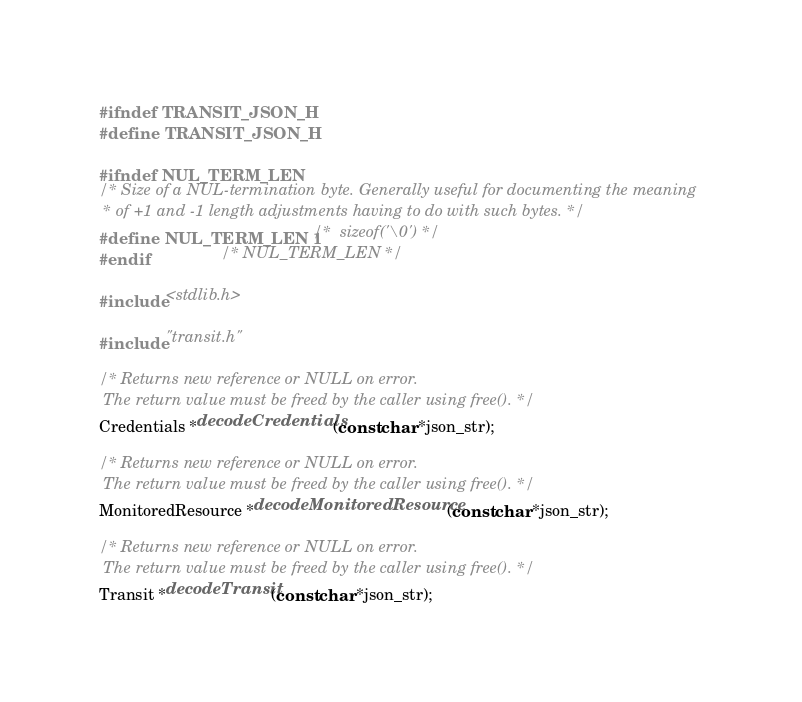<code> <loc_0><loc_0><loc_500><loc_500><_C_>#ifndef TRANSIT_JSON_H
#define TRANSIT_JSON_H

#ifndef NUL_TERM_LEN
/* Size of a NUL-termination byte. Generally useful for documenting the meaning
 * of +1 and -1 length adjustments having to do with such bytes. */
#define NUL_TERM_LEN 1 /*  sizeof('\0') */
#endif                 /* NUL_TERM_LEN */

#include <stdlib.h>

#include "transit.h"

/* Returns new reference or NULL on error.
 The return value must be freed by the caller using free(). */
Credentials *decodeCredentials(const char *json_str);

/* Returns new reference or NULL on error.
 The return value must be freed by the caller using free(). */
MonitoredResource *decodeMonitoredResource(const char *json_str);

/* Returns new reference or NULL on error.
 The return value must be freed by the caller using free(). */
Transit *decodeTransit(const char *json_str);
</code> 